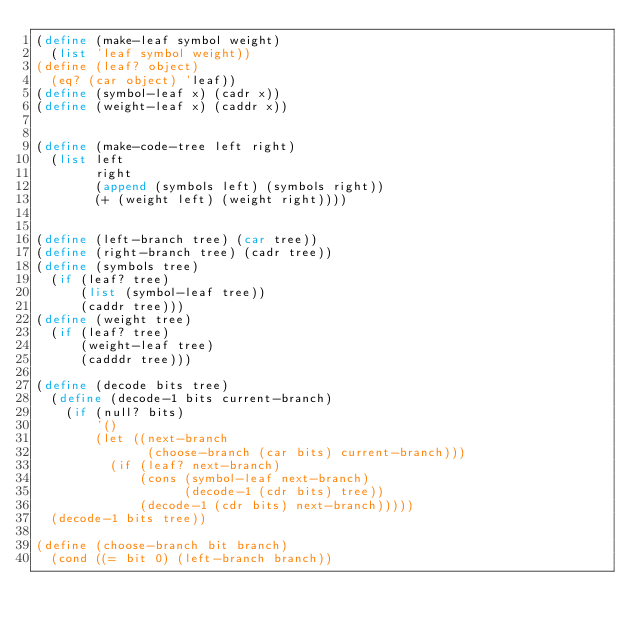<code> <loc_0><loc_0><loc_500><loc_500><_Scheme_>(define (make-leaf symbol weight)
  (list 'leaf symbol weight))
(define (leaf? object)
  (eq? (car object) 'leaf))
(define (symbol-leaf x) (cadr x))
(define (weight-leaf x) (caddr x))


(define (make-code-tree left right)
  (list left
        right
        (append (symbols left) (symbols right))
        (+ (weight left) (weight right))))


(define (left-branch tree) (car tree))
(define (right-branch tree) (cadr tree))
(define (symbols tree)
  (if (leaf? tree)
      (list (symbol-leaf tree))
      (caddr tree)))
(define (weight tree)
  (if (leaf? tree)
      (weight-leaf tree)
      (cadddr tree)))

(define (decode bits tree)
  (define (decode-1 bits current-branch)
    (if (null? bits)
        '()
        (let ((next-branch
               (choose-branch (car bits) current-branch)))
          (if (leaf? next-branch)
              (cons (symbol-leaf next-branch)
                    (decode-1 (cdr bits) tree))
              (decode-1 (cdr bits) next-branch)))))
  (decode-1 bits tree))

(define (choose-branch bit branch)
  (cond ((= bit 0) (left-branch branch))</code> 